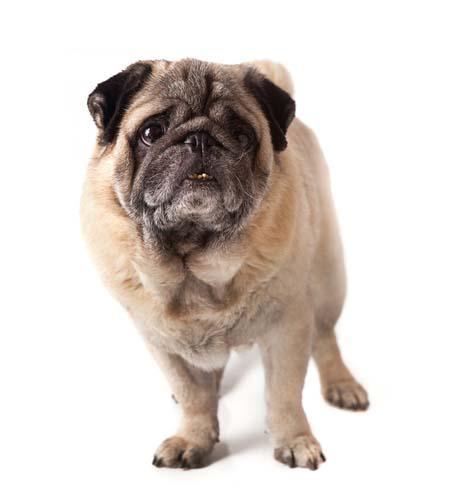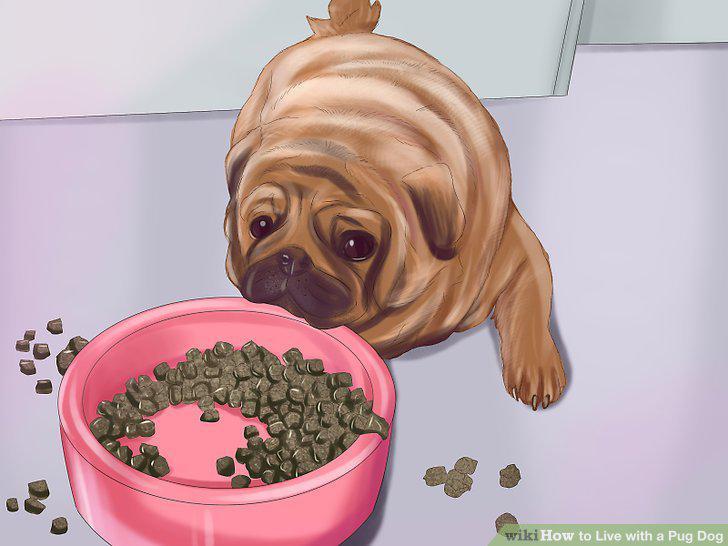The first image is the image on the left, the second image is the image on the right. Assess this claim about the two images: "An image shows one pug dog with one pet food bowl.". Correct or not? Answer yes or no. Yes. The first image is the image on the left, the second image is the image on the right. Considering the images on both sides, is "There is no more than one dog in the left image and it has no dog food." valid? Answer yes or no. Yes. 